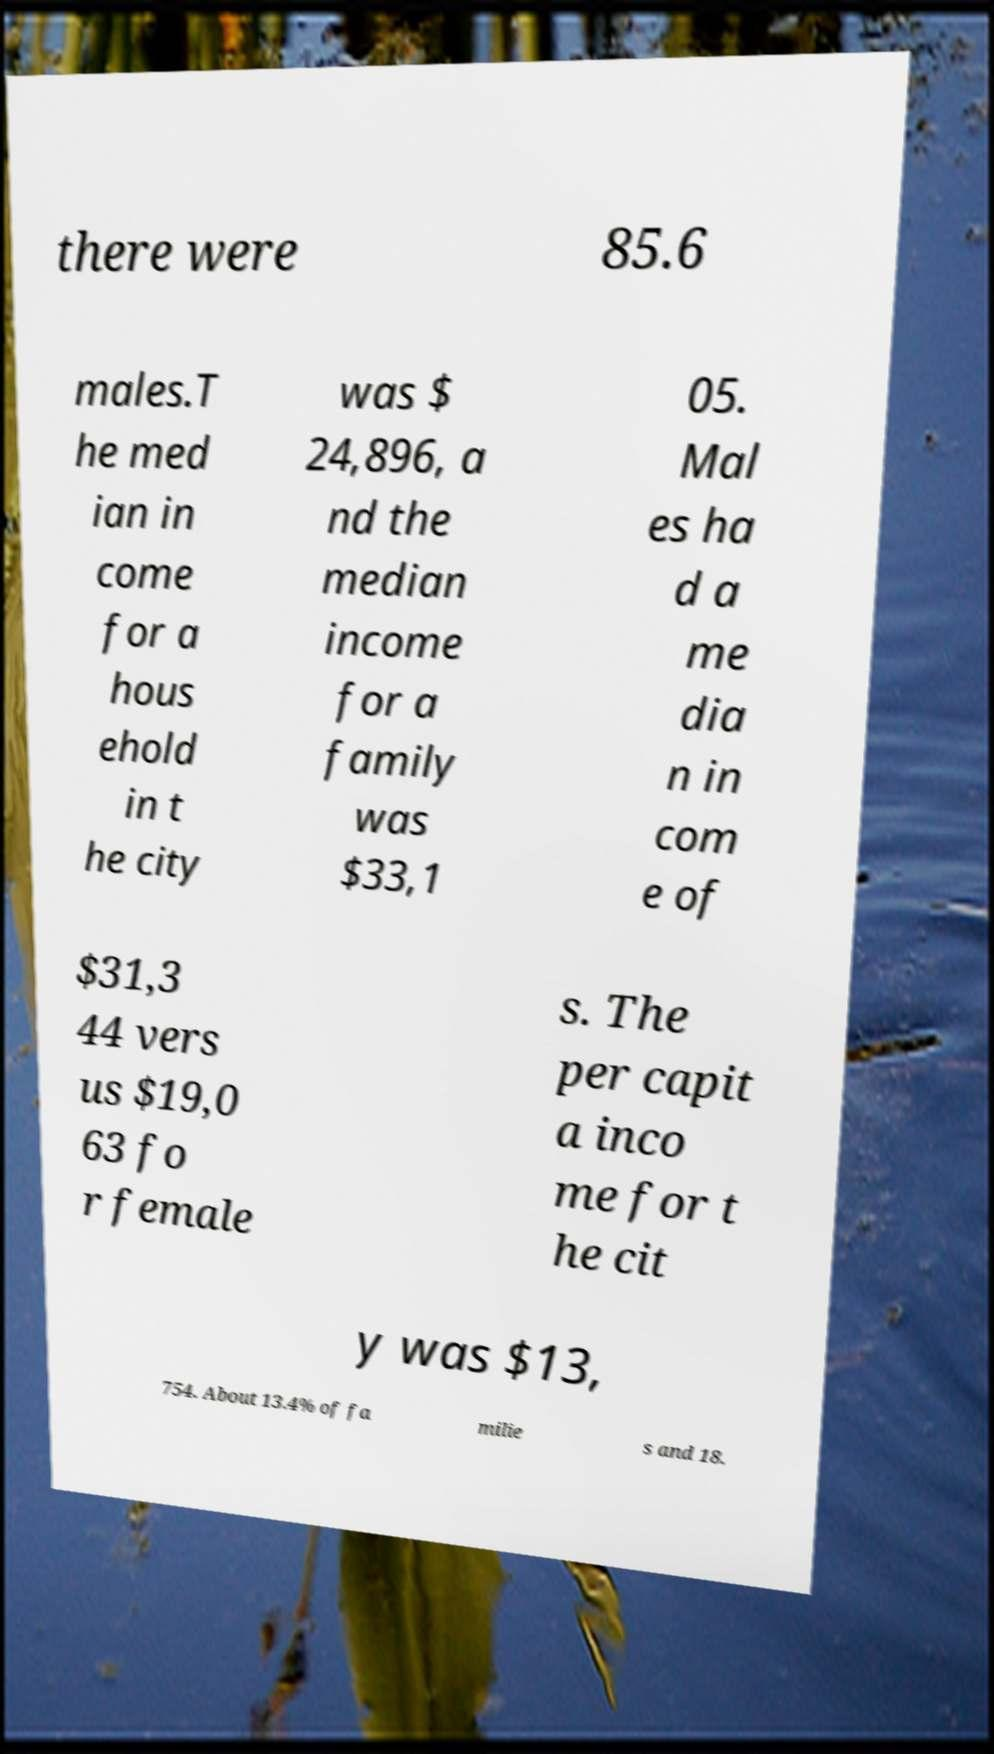I need the written content from this picture converted into text. Can you do that? there were 85.6 males.T he med ian in come for a hous ehold in t he city was $ 24,896, a nd the median income for a family was $33,1 05. Mal es ha d a me dia n in com e of $31,3 44 vers us $19,0 63 fo r female s. The per capit a inco me for t he cit y was $13, 754. About 13.4% of fa milie s and 18. 